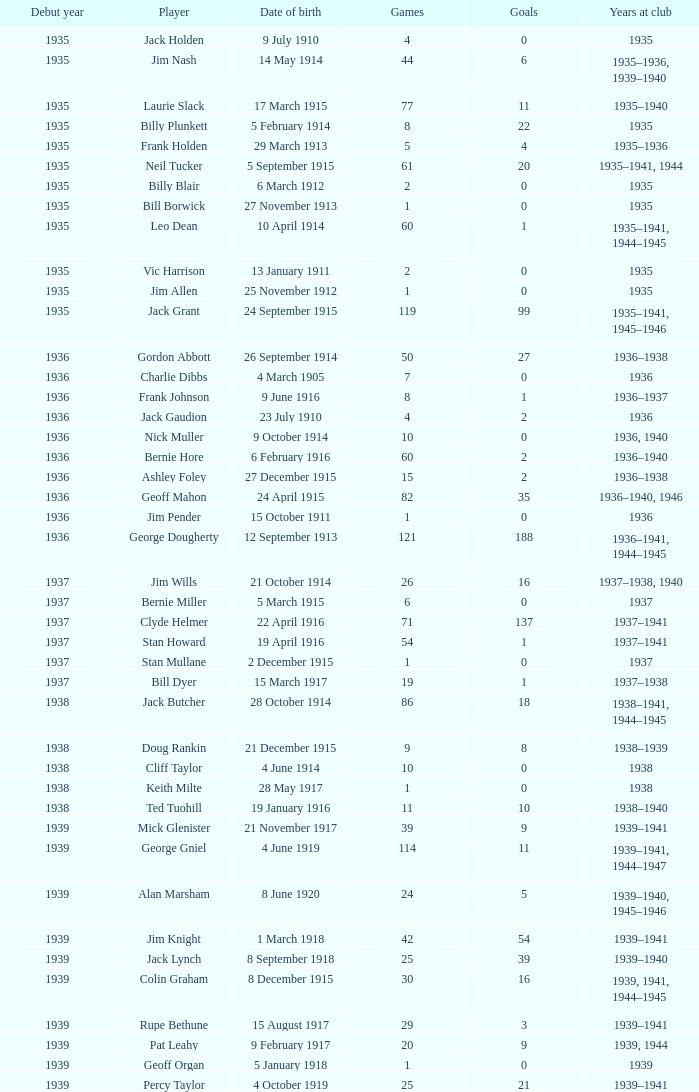What is the average games a player born on 17 March 1915 and debut before 1935 had? None. 